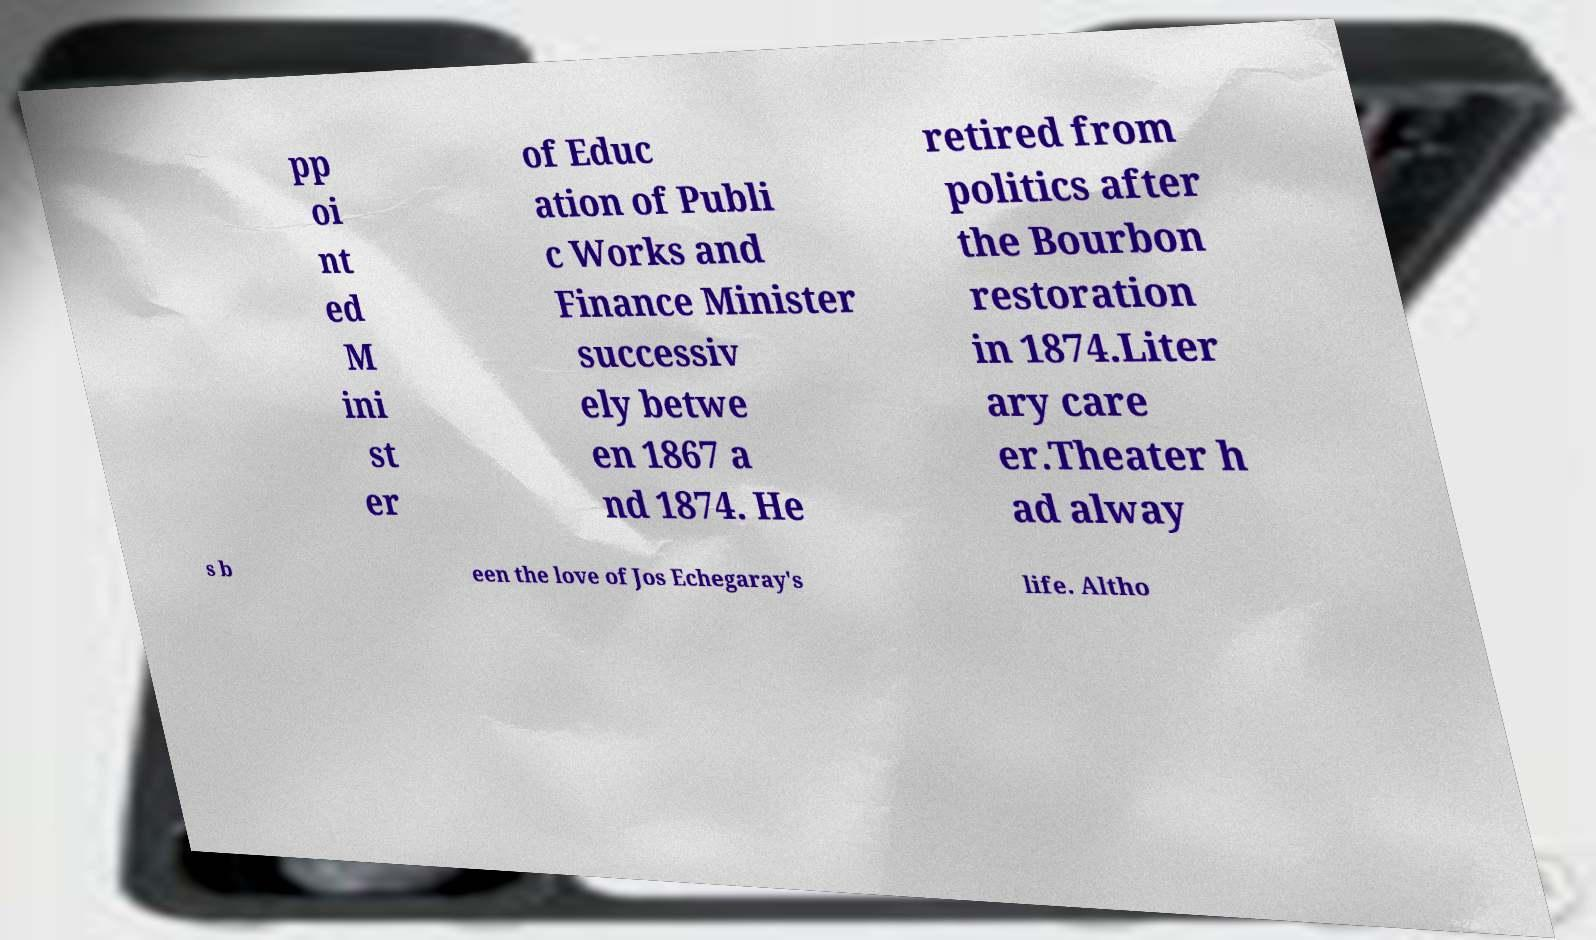Can you accurately transcribe the text from the provided image for me? pp oi nt ed M ini st er of Educ ation of Publi c Works and Finance Minister successiv ely betwe en 1867 a nd 1874. He retired from politics after the Bourbon restoration in 1874.Liter ary care er.Theater h ad alway s b een the love of Jos Echegaray's life. Altho 